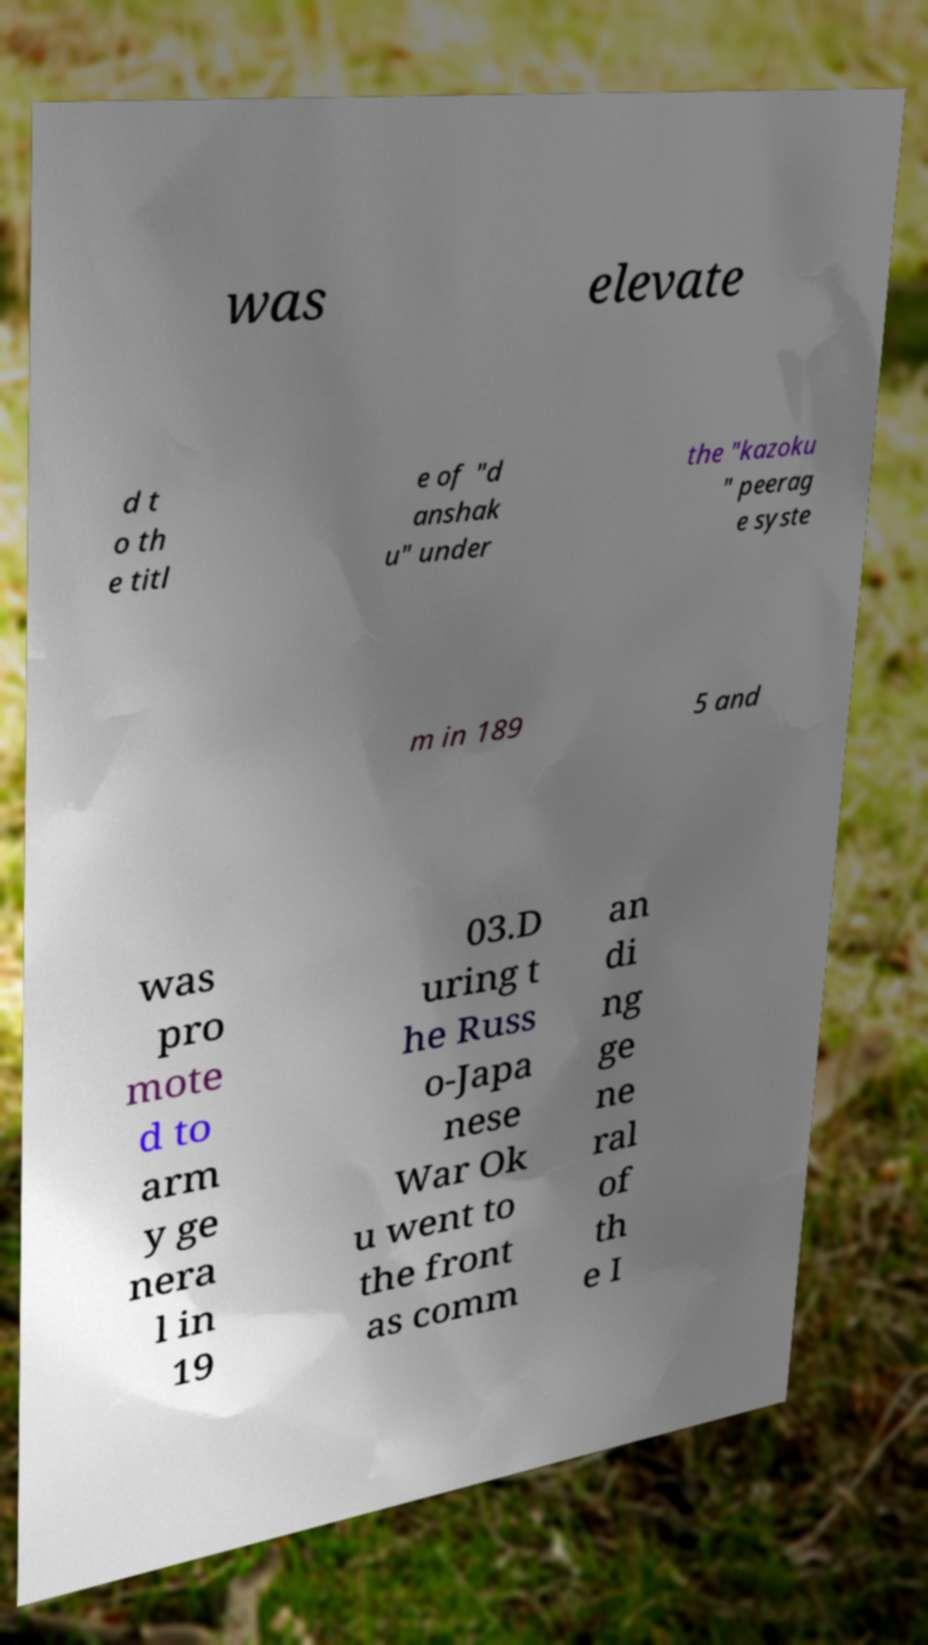There's text embedded in this image that I need extracted. Can you transcribe it verbatim? was elevate d t o th e titl e of "d anshak u" under the "kazoku " peerag e syste m in 189 5 and was pro mote d to arm y ge nera l in 19 03.D uring t he Russ o-Japa nese War Ok u went to the front as comm an di ng ge ne ral of th e I 